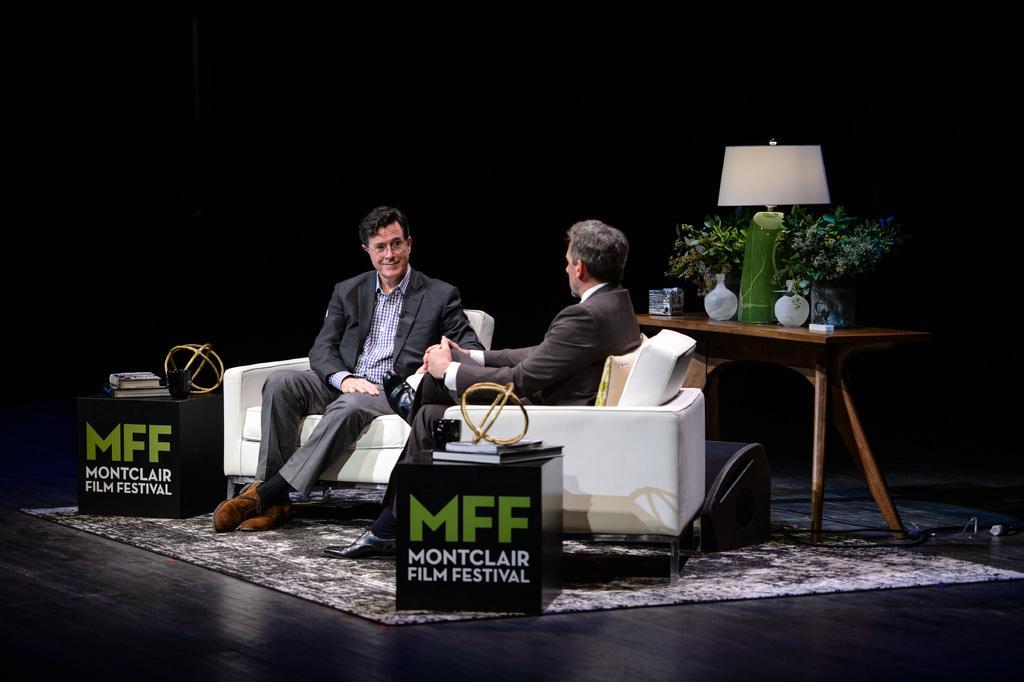In one or two sentences, can you explain what this image depicts? In the image we can see there are two people who are sitting on the chair. 